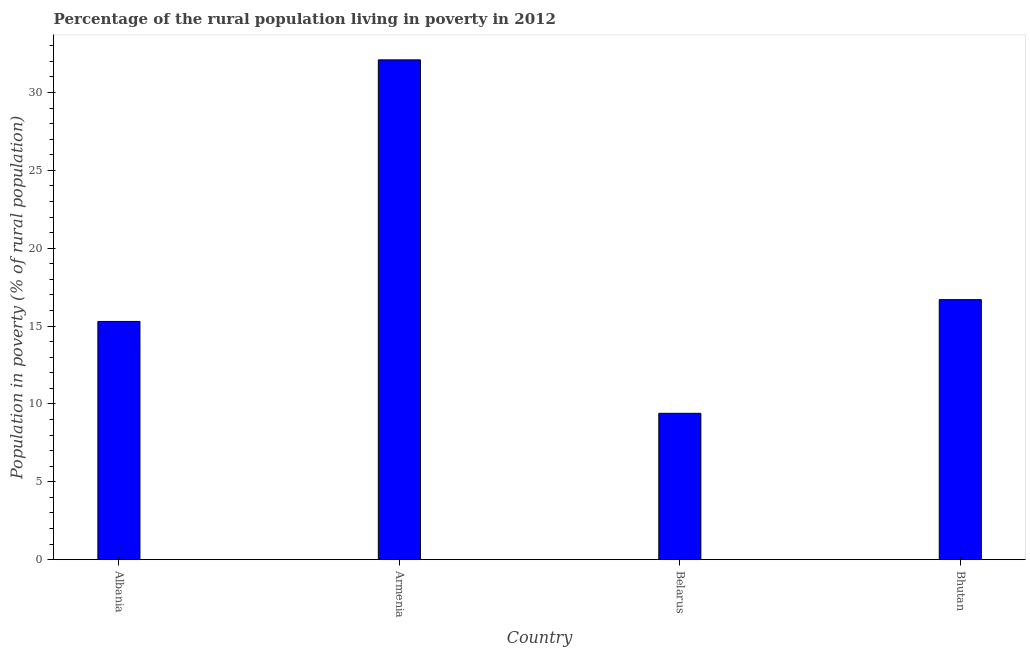Does the graph contain any zero values?
Your answer should be very brief. No. Does the graph contain grids?
Provide a short and direct response. No. What is the title of the graph?
Give a very brief answer. Percentage of the rural population living in poverty in 2012. What is the label or title of the X-axis?
Make the answer very short. Country. What is the label or title of the Y-axis?
Keep it short and to the point. Population in poverty (% of rural population). Across all countries, what is the maximum percentage of rural population living below poverty line?
Your response must be concise. 32.1. Across all countries, what is the minimum percentage of rural population living below poverty line?
Make the answer very short. 9.4. In which country was the percentage of rural population living below poverty line maximum?
Provide a succinct answer. Armenia. In which country was the percentage of rural population living below poverty line minimum?
Provide a short and direct response. Belarus. What is the sum of the percentage of rural population living below poverty line?
Provide a short and direct response. 73.5. What is the difference between the percentage of rural population living below poverty line in Albania and Armenia?
Provide a short and direct response. -16.8. What is the average percentage of rural population living below poverty line per country?
Provide a succinct answer. 18.38. What is the median percentage of rural population living below poverty line?
Your answer should be compact. 16. What is the ratio of the percentage of rural population living below poverty line in Albania to that in Belarus?
Provide a succinct answer. 1.63. Is the percentage of rural population living below poverty line in Albania less than that in Bhutan?
Keep it short and to the point. Yes. What is the difference between the highest and the second highest percentage of rural population living below poverty line?
Offer a very short reply. 15.4. What is the difference between the highest and the lowest percentage of rural population living below poverty line?
Make the answer very short. 22.7. How many bars are there?
Make the answer very short. 4. Are all the bars in the graph horizontal?
Provide a succinct answer. No. How many countries are there in the graph?
Your answer should be compact. 4. What is the Population in poverty (% of rural population) of Albania?
Your response must be concise. 15.3. What is the Population in poverty (% of rural population) in Armenia?
Provide a short and direct response. 32.1. What is the Population in poverty (% of rural population) in Belarus?
Keep it short and to the point. 9.4. What is the difference between the Population in poverty (% of rural population) in Albania and Armenia?
Ensure brevity in your answer.  -16.8. What is the difference between the Population in poverty (% of rural population) in Albania and Belarus?
Keep it short and to the point. 5.9. What is the difference between the Population in poverty (% of rural population) in Albania and Bhutan?
Make the answer very short. -1.4. What is the difference between the Population in poverty (% of rural population) in Armenia and Belarus?
Offer a very short reply. 22.7. What is the difference between the Population in poverty (% of rural population) in Belarus and Bhutan?
Your answer should be compact. -7.3. What is the ratio of the Population in poverty (% of rural population) in Albania to that in Armenia?
Provide a succinct answer. 0.48. What is the ratio of the Population in poverty (% of rural population) in Albania to that in Belarus?
Your answer should be compact. 1.63. What is the ratio of the Population in poverty (% of rural population) in Albania to that in Bhutan?
Offer a terse response. 0.92. What is the ratio of the Population in poverty (% of rural population) in Armenia to that in Belarus?
Keep it short and to the point. 3.42. What is the ratio of the Population in poverty (% of rural population) in Armenia to that in Bhutan?
Provide a succinct answer. 1.92. What is the ratio of the Population in poverty (% of rural population) in Belarus to that in Bhutan?
Your answer should be compact. 0.56. 